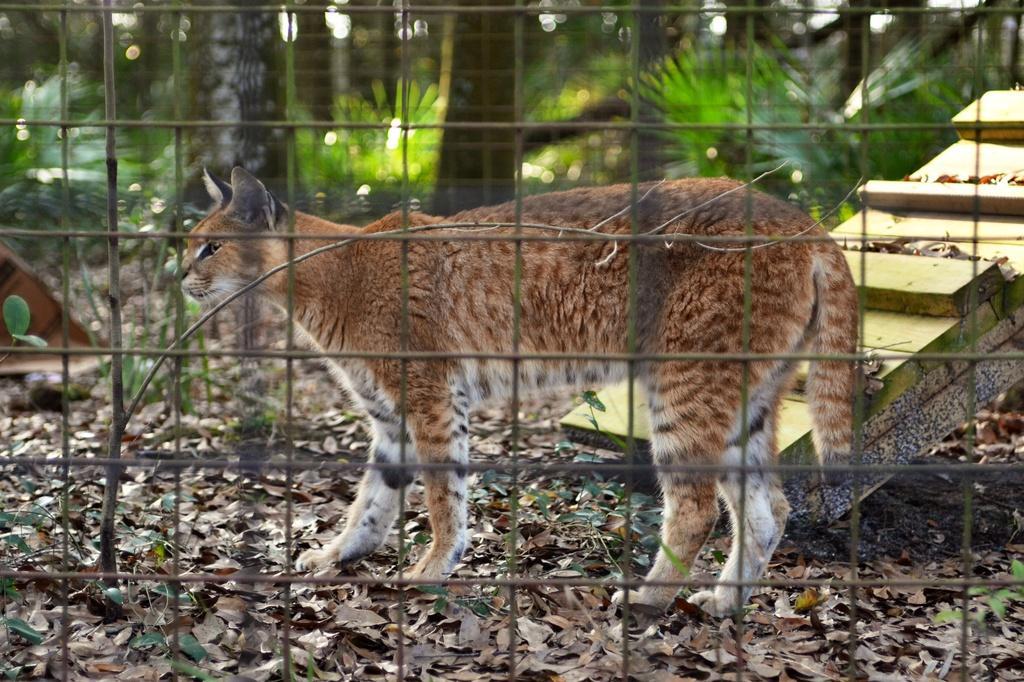Please provide a concise description of this image. In the center of the image there is a cat. In the foreground we can see a mesh. In the background there are trees. 